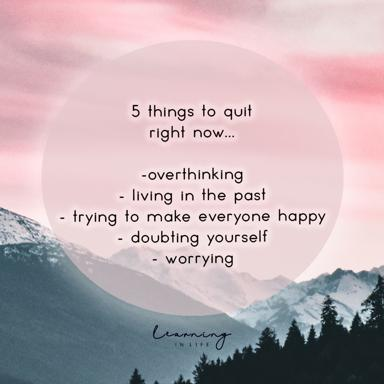Can you list the 5 things mentioned in the image that should be quit right now? The image highlights five behavior patterns to abandon for better mental health:
1. Overthinking - Avoid excessive rumination to free your mind.
2. Living in the past - Focus on the present and future to enhance well-being.
3. Trying to make everyone happy - Understand that you can't please everyone, and prioritize your own happiness.
4. Doubting yourself - Build confidence by trusting in your abilities and decisions.
5. Worrying - Reduce anxiety by managing what's within your control and letting go of what isn't. 